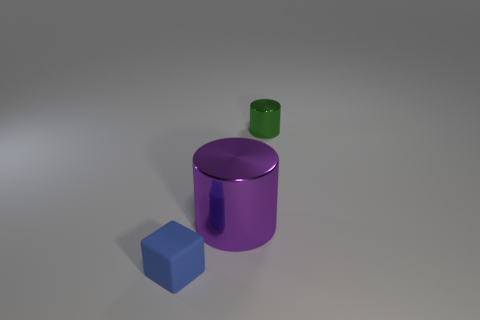Add 1 small blocks. How many objects exist? 4 Subtract all cylinders. How many objects are left? 1 Add 3 small blue blocks. How many small blue blocks are left? 4 Add 1 big gray metallic cylinders. How many big gray metallic cylinders exist? 1 Subtract 0 cyan cubes. How many objects are left? 3 Subtract all small red metallic cylinders. Subtract all tiny cylinders. How many objects are left? 2 